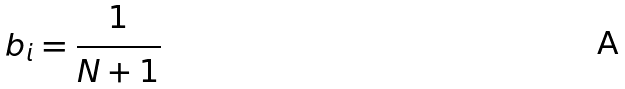Convert formula to latex. <formula><loc_0><loc_0><loc_500><loc_500>b _ { i } = \frac { 1 } { N + 1 }</formula> 